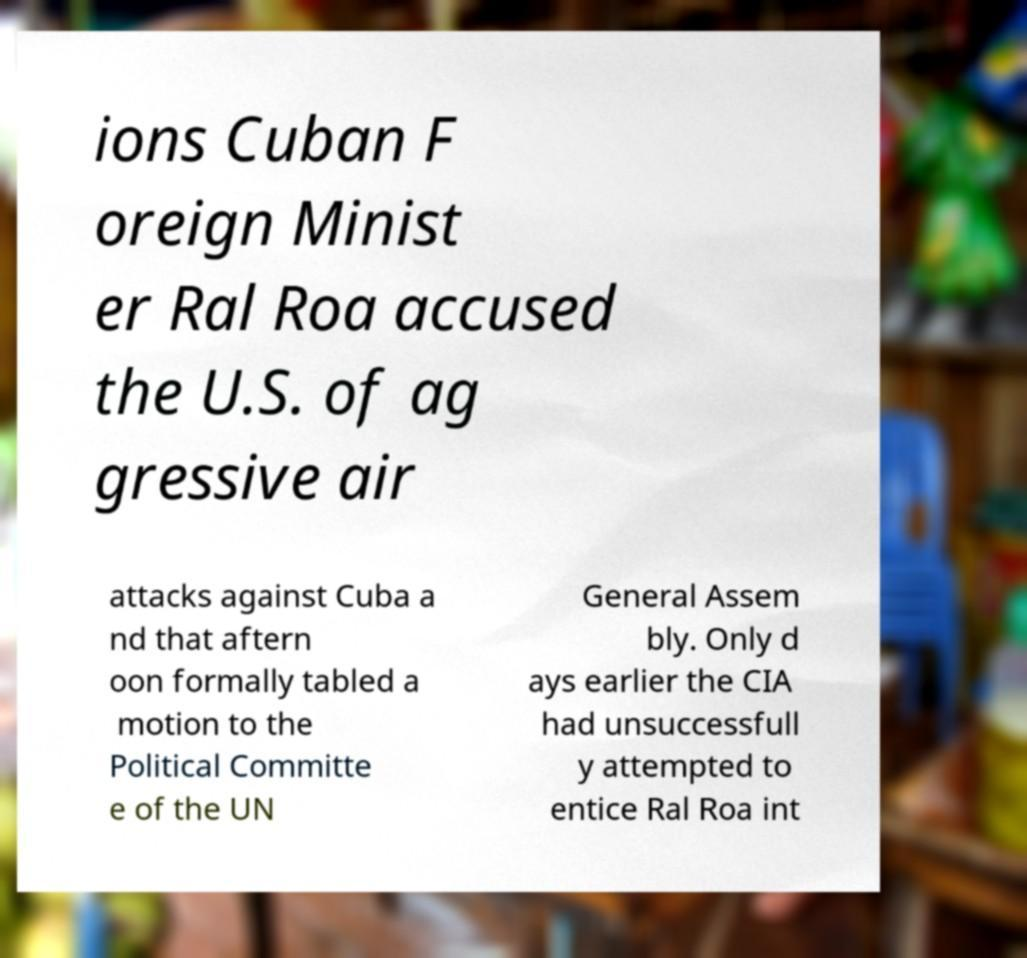Please identify and transcribe the text found in this image. ions Cuban F oreign Minist er Ral Roa accused the U.S. of ag gressive air attacks against Cuba a nd that aftern oon formally tabled a motion to the Political Committe e of the UN General Assem bly. Only d ays earlier the CIA had unsuccessfull y attempted to entice Ral Roa int 